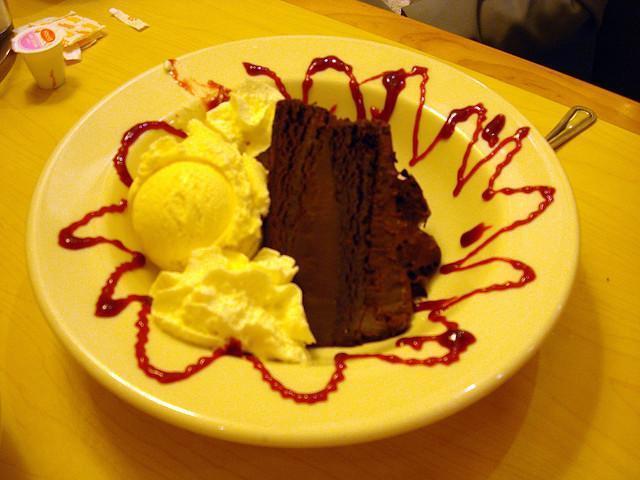How many dining tables are there?
Give a very brief answer. 1. How many cakes can be seen?
Give a very brief answer. 1. 